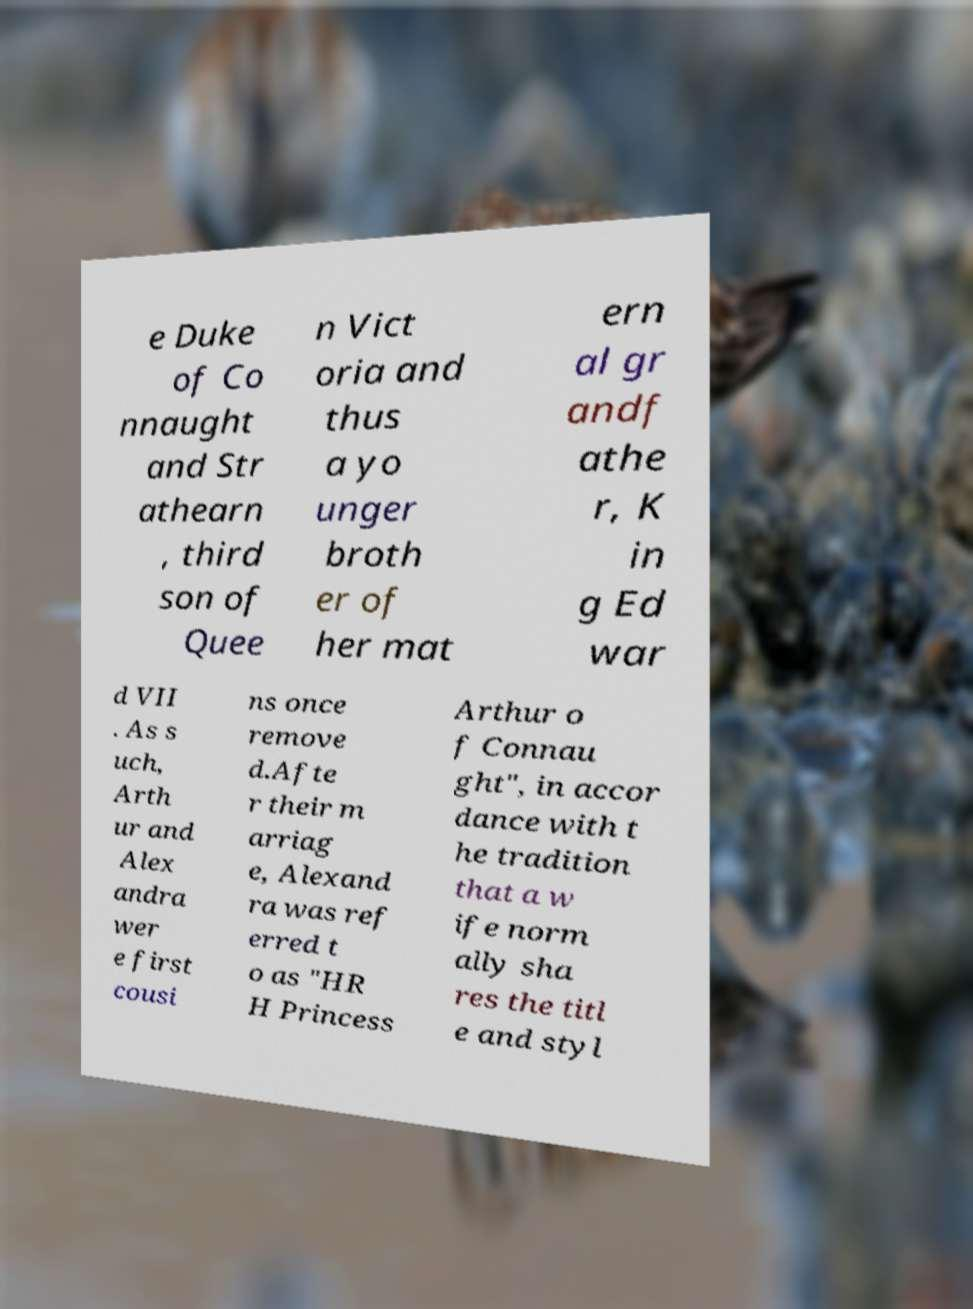Can you read and provide the text displayed in the image?This photo seems to have some interesting text. Can you extract and type it out for me? e Duke of Co nnaught and Str athearn , third son of Quee n Vict oria and thus a yo unger broth er of her mat ern al gr andf athe r, K in g Ed war d VII . As s uch, Arth ur and Alex andra wer e first cousi ns once remove d.Afte r their m arriag e, Alexand ra was ref erred t o as "HR H Princess Arthur o f Connau ght", in accor dance with t he tradition that a w ife norm ally sha res the titl e and styl 